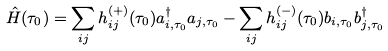Convert formula to latex. <formula><loc_0><loc_0><loc_500><loc_500>\hat { H } ( \tau _ { 0 } ) = \sum _ { i j } h ^ { ( + ) } _ { i j } ( \tau _ { 0 } ) a ^ { \dagger } _ { i , \tau _ { 0 } } a _ { j , \tau _ { 0 } } - \sum _ { i j } h ^ { ( - ) } _ { i j } ( \tau _ { 0 } ) b _ { i , \tau _ { 0 } } b ^ { \dagger } _ { j , \tau _ { 0 } }</formula> 